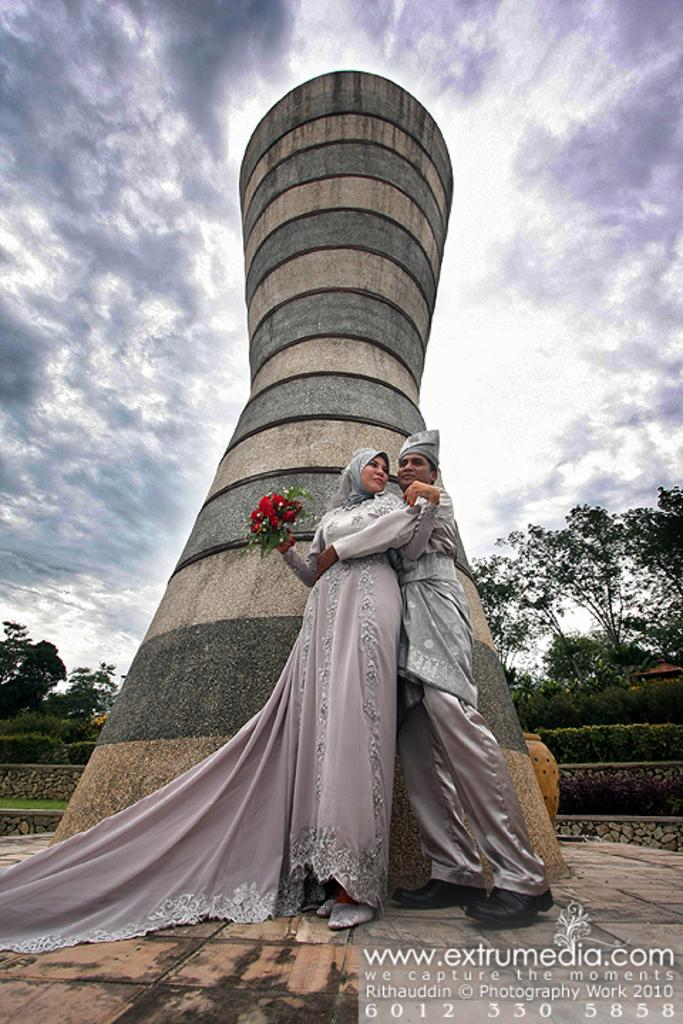Who are the two people in the image? There is a couple in the image. What is the woman holding in her hand? The woman is holding a book in her hand. What is the shape of the wall behind the couple? There is a round wall behind the couple. What can be seen in the background of the image? There are trees, plants, and the sky visible in the background of the image. What type of friction can be seen between the couple in the image? There is no friction visible between the couple in the image; they are simply standing together. How many pets are visible in the image? There are no pets present in the image. 